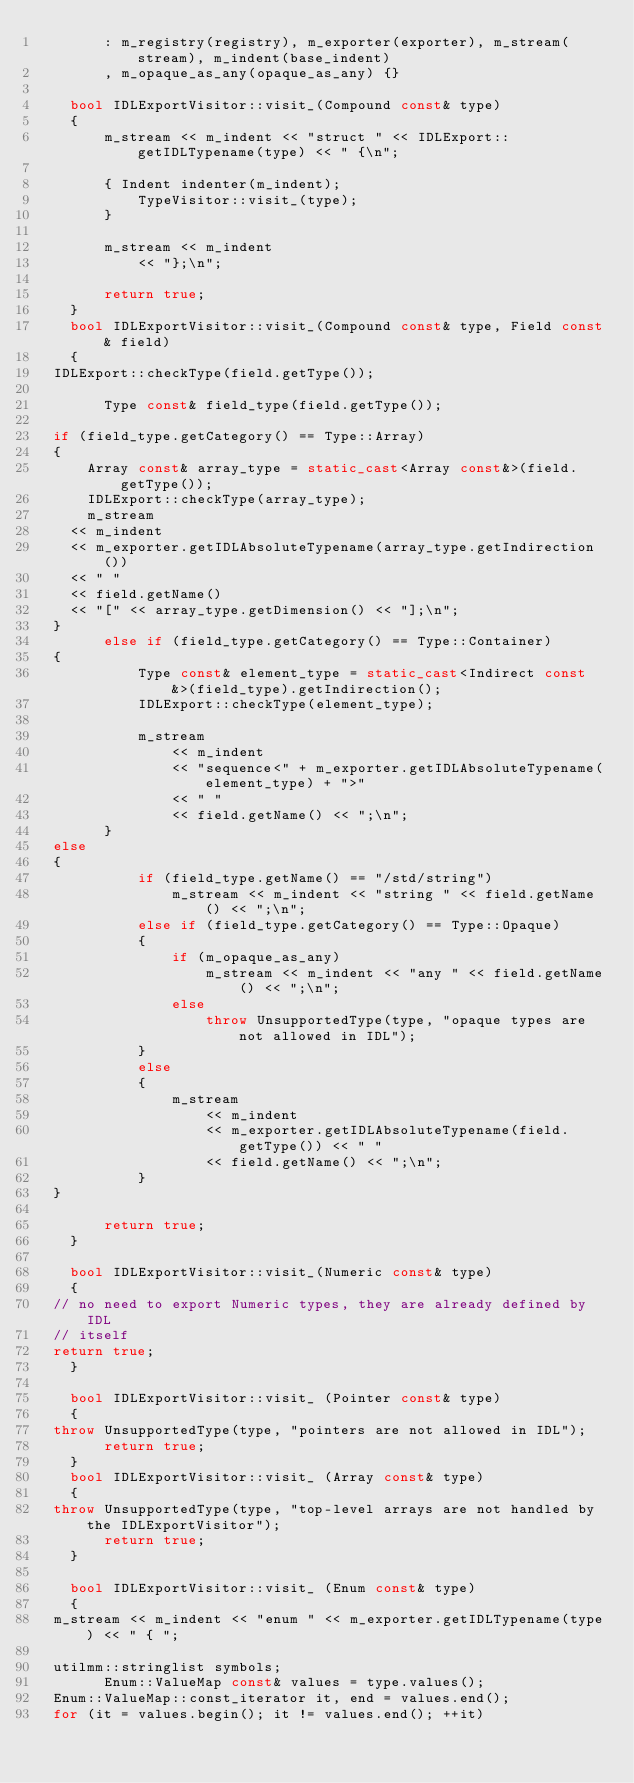Convert code to text. <code><loc_0><loc_0><loc_500><loc_500><_C++_>        : m_registry(registry), m_exporter(exporter), m_stream(stream), m_indent(base_indent)
        , m_opaque_as_any(opaque_as_any) {}

    bool IDLExportVisitor::visit_(Compound const& type)
    { 
        m_stream << m_indent << "struct " << IDLExport::getIDLTypename(type) << " {\n";
        
        { Indent indenter(m_indent);
            TypeVisitor::visit_(type);
        }

        m_stream << m_indent
            << "};\n";

        return true;
    }
    bool IDLExportVisitor::visit_(Compound const& type, Field const& field)
    { 
	IDLExport::checkType(field.getType());

        Type const& field_type(field.getType());

	if (field_type.getCategory() == Type::Array)
	{
	    Array const& array_type = static_cast<Array const&>(field.getType());
	    IDLExport::checkType(array_type);
	    m_stream
		<< m_indent
		<< m_exporter.getIDLAbsoluteTypename(array_type.getIndirection())
		<< " "
		<< field.getName()
		<< "[" << array_type.getDimension() << "];\n";
	}
        else if (field_type.getCategory() == Type::Container)
	{
            Type const& element_type = static_cast<Indirect const&>(field_type).getIndirection();
            IDLExport::checkType(element_type);

            m_stream
                << m_indent
                << "sequence<" + m_exporter.getIDLAbsoluteTypename(element_type) + ">"
                << " "
                << field.getName() << ";\n";
        }
	else
	{
            if (field_type.getName() == "/std/string")
                m_stream << m_indent << "string " << field.getName() << ";\n";
            else if (field_type.getCategory() == Type::Opaque)
            {
                if (m_opaque_as_any)
                    m_stream << m_indent << "any " << field.getName() << ";\n";
                else
                    throw UnsupportedType(type, "opaque types are not allowed in IDL");
            }
            else
            {
                m_stream 
                    << m_indent
                    << m_exporter.getIDLAbsoluteTypename(field.getType()) << " "
                    << field.getName() << ";\n";
            }
	}

        return true;
    }

    bool IDLExportVisitor::visit_(Numeric const& type)
    {
	// no need to export Numeric types, they are already defined by IDL
	// itself
	return true;
    }

    bool IDLExportVisitor::visit_ (Pointer const& type)
    {
	throw UnsupportedType(type, "pointers are not allowed in IDL");
        return true;
    }
    bool IDLExportVisitor::visit_ (Array const& type)
    {
	throw UnsupportedType(type, "top-level arrays are not handled by the IDLExportVisitor");
        return true;
    }

    bool IDLExportVisitor::visit_ (Enum const& type)
    {
	m_stream << m_indent << "enum " << m_exporter.getIDLTypename(type) << " { ";

	utilmm::stringlist symbols;
        Enum::ValueMap const& values = type.values();
	Enum::ValueMap::const_iterator it, end = values.end();
	for (it = values.begin(); it != values.end(); ++it)</code> 